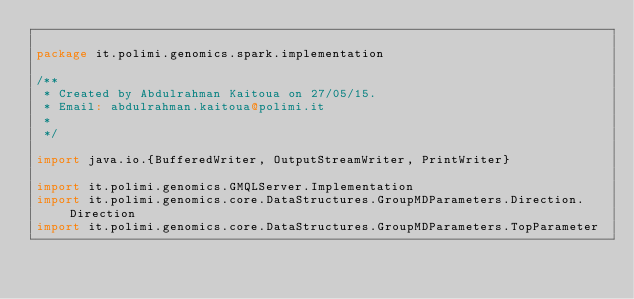<code> <loc_0><loc_0><loc_500><loc_500><_Scala_>
package it.polimi.genomics.spark.implementation

/**
 * Created by Abdulrahman Kaitoua on 27/05/15.
 * Email: abdulrahman.kaitoua@polimi.it
 *
 */

import java.io.{BufferedWriter, OutputStreamWriter, PrintWriter}

import it.polimi.genomics.GMQLServer.Implementation
import it.polimi.genomics.core.DataStructures.GroupMDParameters.Direction.Direction
import it.polimi.genomics.core.DataStructures.GroupMDParameters.TopParameter</code> 